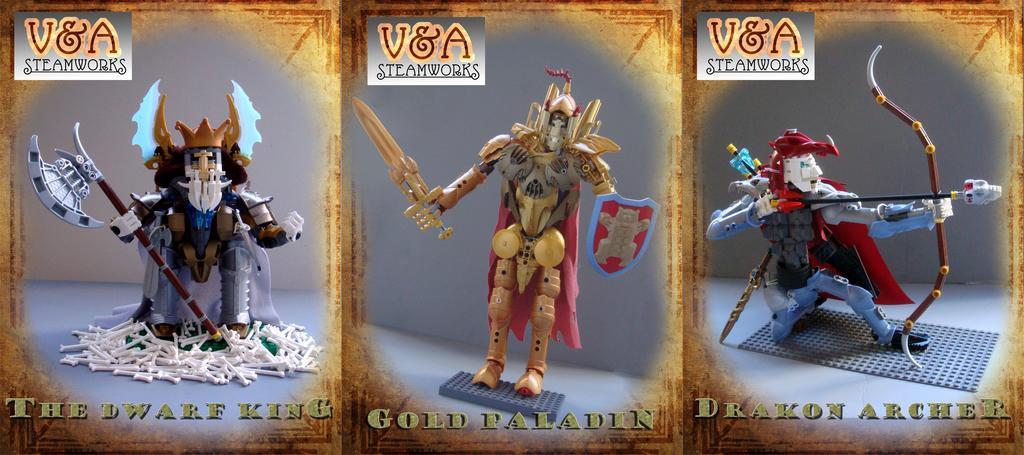In one or two sentences, can you explain what this image depicts? This is an animated image. In this picture, we see three toys. The toy on the left side is holding the axe. The toy in the middle of the picture is holding the sword and the shield. The toy on the right side is holding the bow and arrow. At the bottom, we see some text written on it. This might be an edited image. 